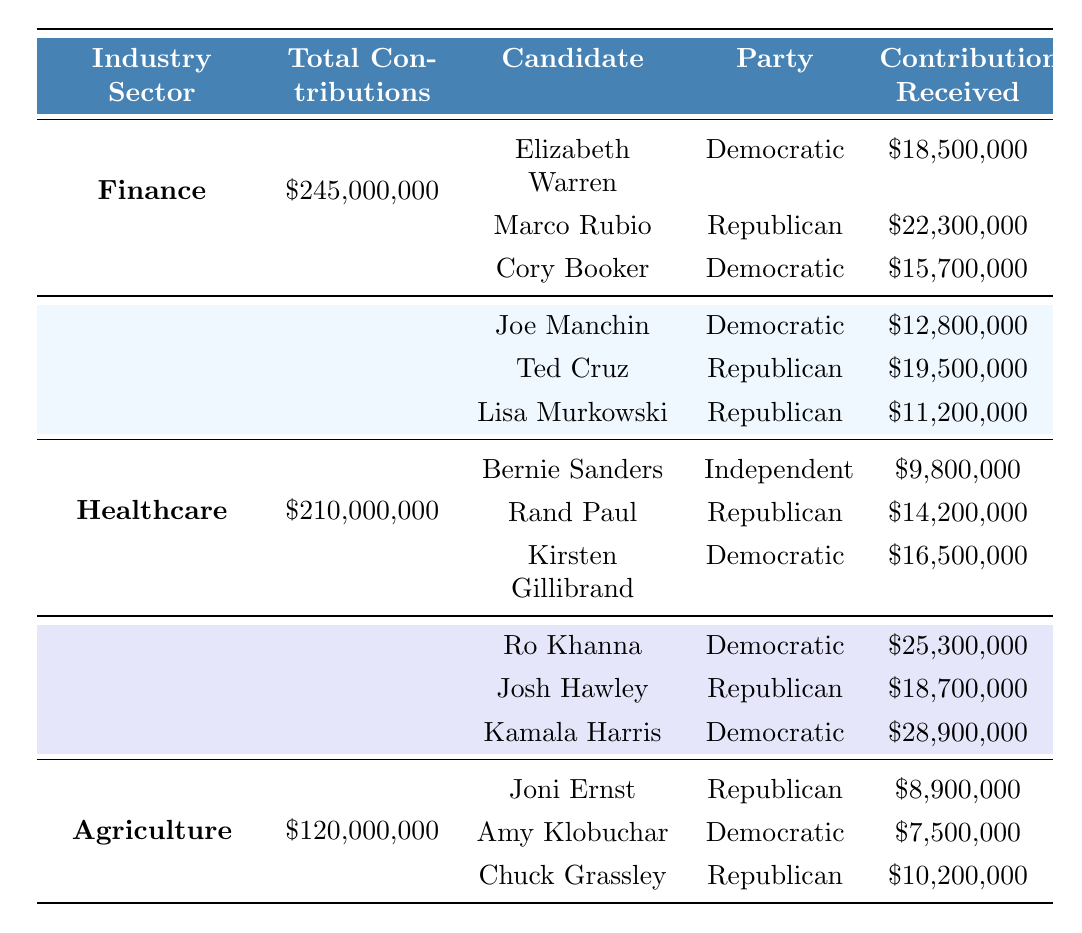What is the total amount of contributions in the Finance sector? The table shows that the total contributions in the Finance sector are listed as $245,000,000.
Answer: $245,000,000 How much did Elizabeth Warren receive in contributions? Referring to the Finance section of the table, Elizabeth Warren received $18,500,000 in contributions.
Answer: $18,500,000 Which candidate from the Agriculture sector received the least amount of contributions? In the Agriculture section, the candidates and their contributions are: Joni Ernst with $8,900,000, Amy Klobuchar with $7,500,000, and Chuck Grassley with $10,200,000. The least received is Amy Klobuchar at $7,500,000.
Answer: Amy Klobuchar How many candidates from the Technology sector won their elections? The Technology sector lists three candidates: Ro Khanna (Won), Josh Hawley (Won), and Kamala Harris (Won). All three candidates won their elections.
Answer: 3 What is the total amount of contributions from the Healthcare sector minus the contributions of Kirsten Gillibrand? The total contributions from the Healthcare sector are $210,000,000. Kirsten Gillibrand received $16,500,000. Subtracting this gives $210,000,000 - $16,500,000 = $193,500,000.
Answer: $193,500,000 Did any candidate in the Energy sector receive more contributions than Joe Manchin? Joe Manchin received $12,800,000 in the Energy sector. Comparing with Ted Cruz ($19,500,000) and Lisa Murkowski ($11,200,000), only Ted Cruz received more than Joe Manchin.
Answer: Yes Which industry sector had the highest total contributions? Reviewing the total contributions for each sector: Finance - $245,000,000, Energy - $180,000,000, Healthcare - $210,000,000, Technology - $290,000,000, Agriculture - $120,000,000. Technology has the highest at $290,000,000.
Answer: Technology Calculate the average contributions received by candidates in the Finance sector. In Finance, contributions are: Elizabeth Warren - $18,500,000, Marco Rubio - $22,300,000, Cory Booker - $15,700,000. Summing these gives $18,500,000 + $22,300,000 + $15,700,000 = $56,500,000. Dividing by 3 candidates gives an average of $56,500,000 / 3 = $18,833,333.33.
Answer: $18,833,333.33 Is there a candidate from the Healthcare sector who lost their election? The table shows Kirsten Gillibrand in the Healthcare sector, with the electoral outcome listed as "Lost".
Answer: Yes How many total contributions did all Republican candidates receive combined across all sectors? The Republican candidates are Marco Rubio ($22,300,000) in Finance, Ted Cruz ($19,500,000) and Lisa Murkowski ($11,200,000) in Energy, Rand Paul ($14,200,000) in Healthcare, Josh Hawley ($18,700,000) in Technology, and Joni Ernst ($8,900,000) and Chuck Grassley ($10,200,000) in Agriculture. Summing these gives $22,300,000 + $19,500,000 + $11,200,000 + $14,200,000 + $18,700,000 + $8,900,000 + $10,200,000 = $104,000,000.
Answer: $104,000,000 